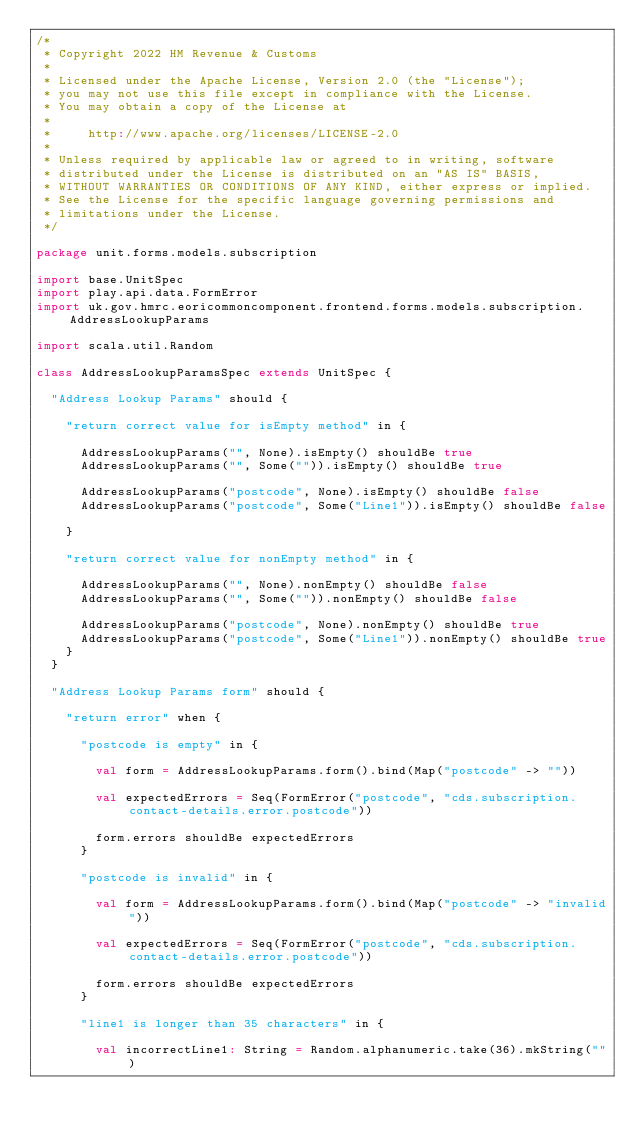Convert code to text. <code><loc_0><loc_0><loc_500><loc_500><_Scala_>/*
 * Copyright 2022 HM Revenue & Customs
 *
 * Licensed under the Apache License, Version 2.0 (the "License");
 * you may not use this file except in compliance with the License.
 * You may obtain a copy of the License at
 *
 *     http://www.apache.org/licenses/LICENSE-2.0
 *
 * Unless required by applicable law or agreed to in writing, software
 * distributed under the License is distributed on an "AS IS" BASIS,
 * WITHOUT WARRANTIES OR CONDITIONS OF ANY KIND, either express or implied.
 * See the License for the specific language governing permissions and
 * limitations under the License.
 */

package unit.forms.models.subscription

import base.UnitSpec
import play.api.data.FormError
import uk.gov.hmrc.eoricommoncomponent.frontend.forms.models.subscription.AddressLookupParams

import scala.util.Random

class AddressLookupParamsSpec extends UnitSpec {

  "Address Lookup Params" should {

    "return correct value for isEmpty method" in {

      AddressLookupParams("", None).isEmpty() shouldBe true
      AddressLookupParams("", Some("")).isEmpty() shouldBe true

      AddressLookupParams("postcode", None).isEmpty() shouldBe false
      AddressLookupParams("postcode", Some("Line1")).isEmpty() shouldBe false

    }

    "return correct value for nonEmpty method" in {

      AddressLookupParams("", None).nonEmpty() shouldBe false
      AddressLookupParams("", Some("")).nonEmpty() shouldBe false

      AddressLookupParams("postcode", None).nonEmpty() shouldBe true
      AddressLookupParams("postcode", Some("Line1")).nonEmpty() shouldBe true
    }
  }

  "Address Lookup Params form" should {

    "return error" when {

      "postcode is empty" in {

        val form = AddressLookupParams.form().bind(Map("postcode" -> ""))

        val expectedErrors = Seq(FormError("postcode", "cds.subscription.contact-details.error.postcode"))

        form.errors shouldBe expectedErrors
      }

      "postcode is invalid" in {

        val form = AddressLookupParams.form().bind(Map("postcode" -> "invalid"))

        val expectedErrors = Seq(FormError("postcode", "cds.subscription.contact-details.error.postcode"))

        form.errors shouldBe expectedErrors
      }

      "line1 is longer than 35 characters" in {

        val incorrectLine1: String = Random.alphanumeric.take(36).mkString("")</code> 